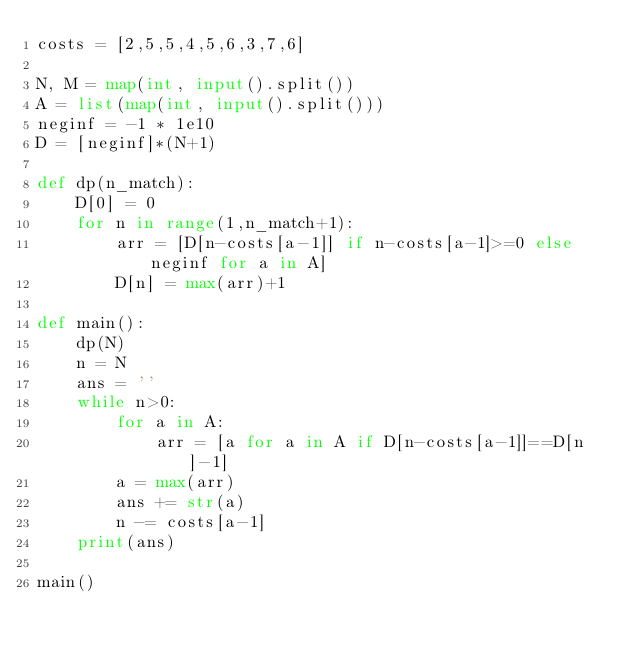Convert code to text. <code><loc_0><loc_0><loc_500><loc_500><_Python_>costs = [2,5,5,4,5,6,3,7,6]

N, M = map(int, input().split())
A = list(map(int, input().split()))
neginf = -1 * 1e10
D = [neginf]*(N+1)

def dp(n_match):
    D[0] = 0
    for n in range(1,n_match+1):
        arr = [D[n-costs[a-1]] if n-costs[a-1]>=0 else neginf for a in A]
        D[n] = max(arr)+1

def main():
    dp(N)
    n = N
    ans = ''
    while n>0:
        for a in A:
            arr = [a for a in A if D[n-costs[a-1]]==D[n]-1]
        a = max(arr)
        ans += str(a)
        n -= costs[a-1]
    print(ans)

main()</code> 